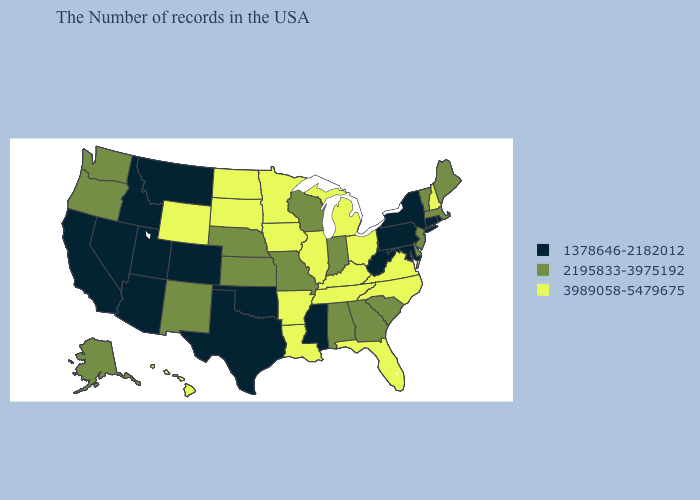What is the value of Idaho?
Answer briefly. 1378646-2182012. Does the first symbol in the legend represent the smallest category?
Quick response, please. Yes. Among the states that border Nebraska , which have the lowest value?
Give a very brief answer. Colorado. Does the map have missing data?
Quick response, please. No. Does Pennsylvania have the lowest value in the Northeast?
Quick response, please. Yes. Is the legend a continuous bar?
Answer briefly. No. What is the lowest value in the USA?
Answer briefly. 1378646-2182012. What is the highest value in the West ?
Answer briefly. 3989058-5479675. Name the states that have a value in the range 2195833-3975192?
Quick response, please. Maine, Massachusetts, Vermont, New Jersey, Delaware, South Carolina, Georgia, Indiana, Alabama, Wisconsin, Missouri, Kansas, Nebraska, New Mexico, Washington, Oregon, Alaska. Does Utah have a higher value than California?
Short answer required. No. Does the map have missing data?
Short answer required. No. What is the value of Ohio?
Give a very brief answer. 3989058-5479675. Among the states that border Iowa , which have the lowest value?
Be succinct. Wisconsin, Missouri, Nebraska. Among the states that border Florida , which have the lowest value?
Quick response, please. Georgia, Alabama. 